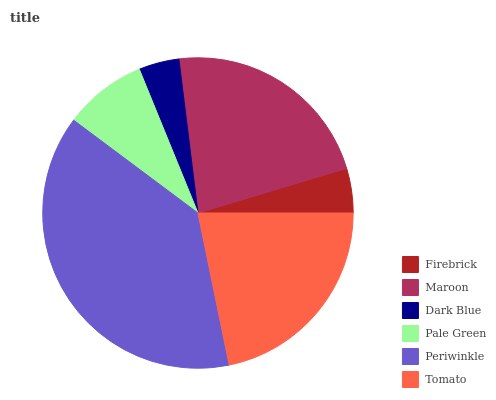Is Dark Blue the minimum?
Answer yes or no. Yes. Is Periwinkle the maximum?
Answer yes or no. Yes. Is Maroon the minimum?
Answer yes or no. No. Is Maroon the maximum?
Answer yes or no. No. Is Maroon greater than Firebrick?
Answer yes or no. Yes. Is Firebrick less than Maroon?
Answer yes or no. Yes. Is Firebrick greater than Maroon?
Answer yes or no. No. Is Maroon less than Firebrick?
Answer yes or no. No. Is Tomato the high median?
Answer yes or no. Yes. Is Pale Green the low median?
Answer yes or no. Yes. Is Periwinkle the high median?
Answer yes or no. No. Is Periwinkle the low median?
Answer yes or no. No. 